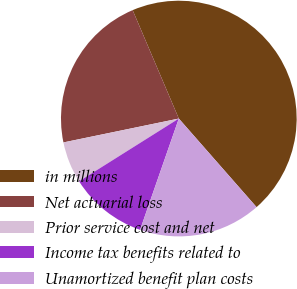Convert chart to OTSL. <chart><loc_0><loc_0><loc_500><loc_500><pie_chart><fcel>in millions<fcel>Net actuarial loss<fcel>Prior service cost and net<fcel>Income tax benefits related to<fcel>Unamortized benefit plan costs<nl><fcel>44.95%<fcel>21.84%<fcel>5.69%<fcel>10.73%<fcel>16.8%<nl></chart> 